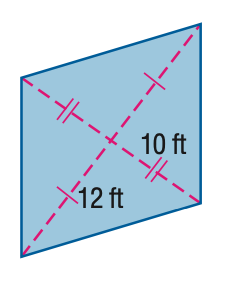Question: Find the area of the kite.
Choices:
A. 120
B. 180
C. 240
D. 300
Answer with the letter. Answer: C 